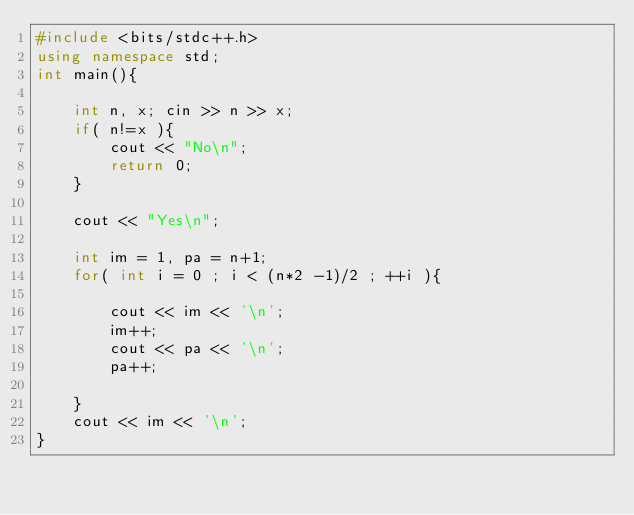<code> <loc_0><loc_0><loc_500><loc_500><_C++_>#include <bits/stdc++.h>
using namespace std;
int main(){

    int n, x; cin >> n >> x;
    if( n!=x ){
        cout << "No\n";
        return 0;
    }

    cout << "Yes\n";

    int im = 1, pa = n+1;
    for( int i = 0 ; i < (n*2 -1)/2 ; ++i ){

        cout << im << '\n';
        im++;
        cout << pa << '\n';
        pa++;

    }
    cout << im << '\n';
}
</code> 